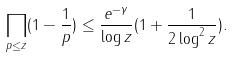Convert formula to latex. <formula><loc_0><loc_0><loc_500><loc_500>\prod _ { p \leq z } ( 1 - \frac { 1 } { p } ) \leq \frac { e ^ { - \gamma } } { \log { z } } ( 1 + \frac { 1 } { 2 \log ^ { 2 } { z } } ) .</formula> 